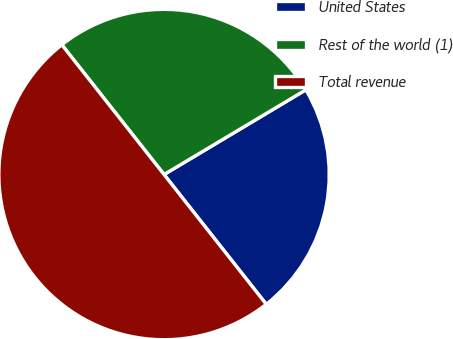Convert chart. <chart><loc_0><loc_0><loc_500><loc_500><pie_chart><fcel>United States<fcel>Rest of the world (1)<fcel>Total revenue<nl><fcel>22.95%<fcel>27.05%<fcel>50.0%<nl></chart> 